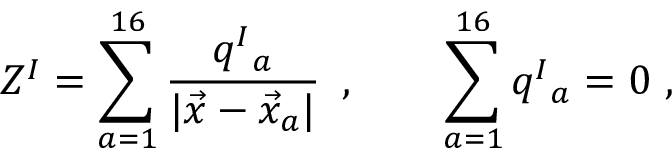<formula> <loc_0><loc_0><loc_500><loc_500>Z ^ { I } = \sum _ { a = 1 } ^ { 1 6 } { \frac { q ^ { I _ { a } } { | \vec { x } - \vec { x } _ { a } | } } \, \ , \quad \sum _ { a = 1 } ^ { 1 6 } q ^ { I _ { a } = 0 \ ,</formula> 